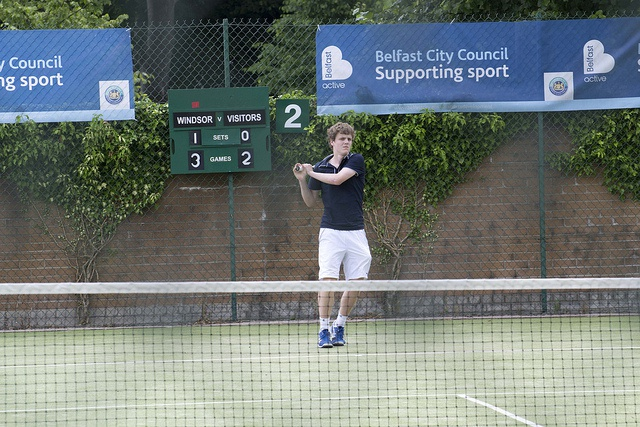Describe the objects in this image and their specific colors. I can see people in darkgreen, lavender, black, gray, and darkgray tones, tennis racket in darkgreen, black, gray, and navy tones, and tennis racket in darkgreen, gray, darkgray, lightgray, and black tones in this image. 